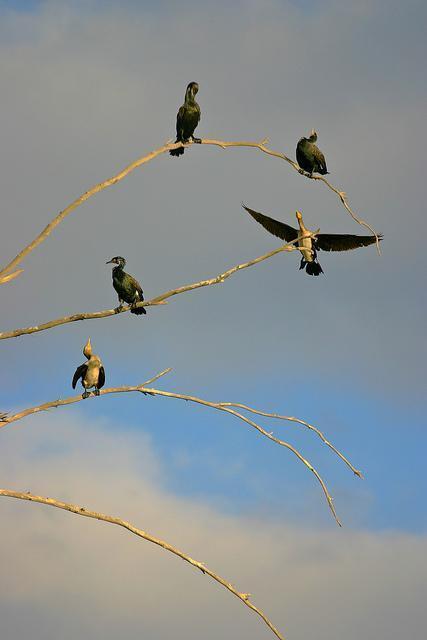How many birds are there?
Give a very brief answer. 5. How many of the birds have their wings spread wide open?
Give a very brief answer. 1. How many people are standing?
Give a very brief answer. 0. 